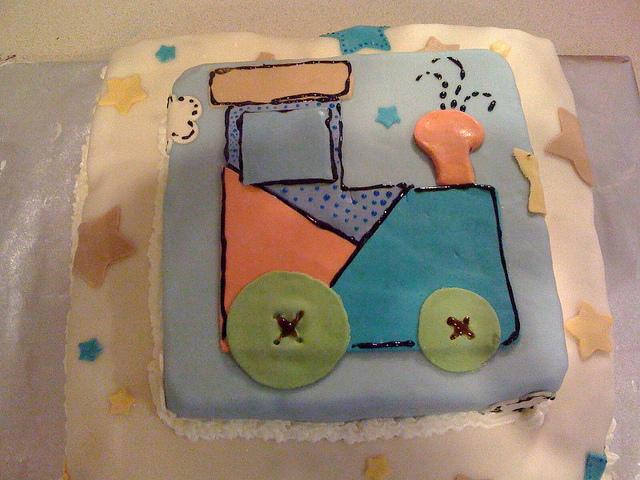What is from space on this cake?
Quick response, please. Stars. What color is the cake?
Short answer required. White and blue. What kind of vehicle is it?
Answer briefly. Train. 